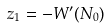Convert formula to latex. <formula><loc_0><loc_0><loc_500><loc_500>z _ { 1 } = - W ^ { \prime } ( N _ { 0 } )</formula> 